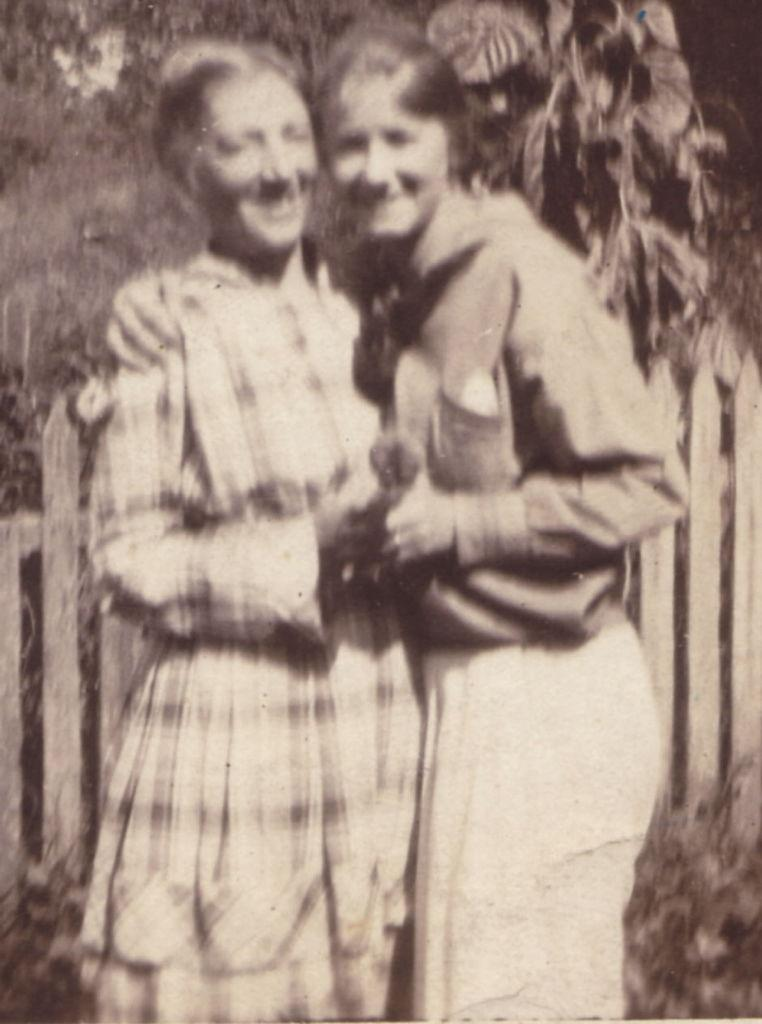What is the color scheme of the image? The image is black and white. How many women are present in the image? There are two women standing in the middle of the image. What can be seen in the background of the image? There is a fence and trees in the background of the image. What type of disease is affecting the women in the image? There is no indication of any disease affecting the women in the image. How does the image stop the spread of the disease? The image does not have any effect on the spread of disease, as it is a static representation and not a real-life situation. 